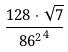<formula> <loc_0><loc_0><loc_500><loc_500>\frac { 1 2 8 \cdot \sqrt { 7 } } { { 8 6 ^ { 2 } } ^ { 4 } }</formula> 